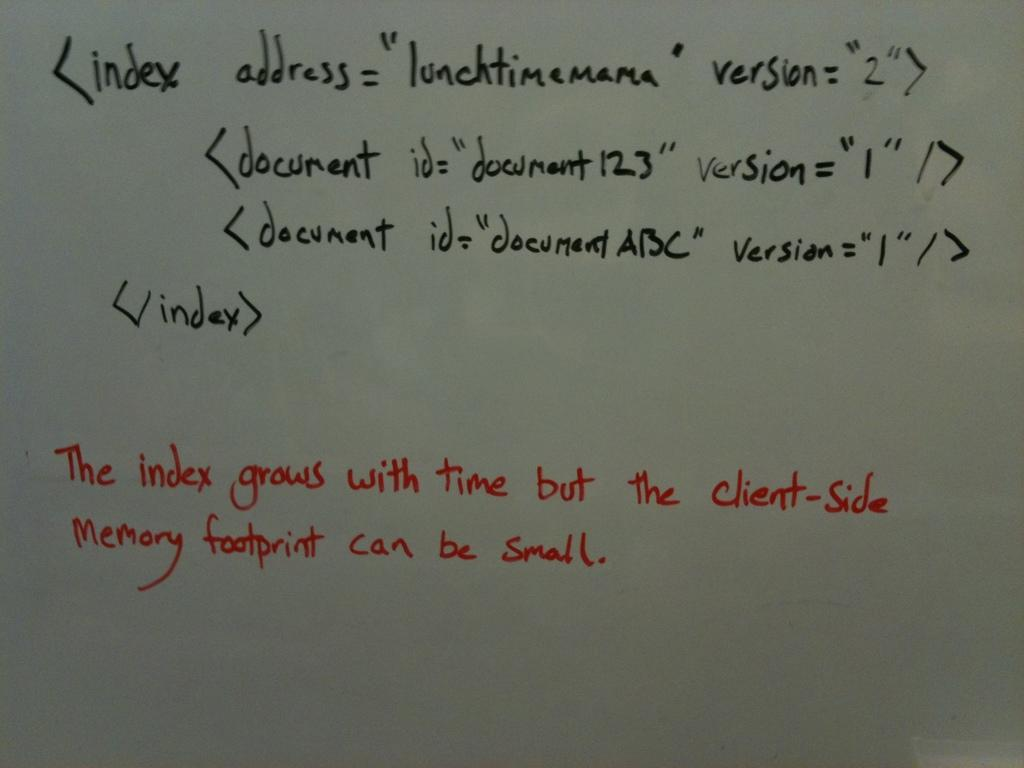<image>
Give a short and clear explanation of the subsequent image. A white board has a complex code that says the index grows with time. 